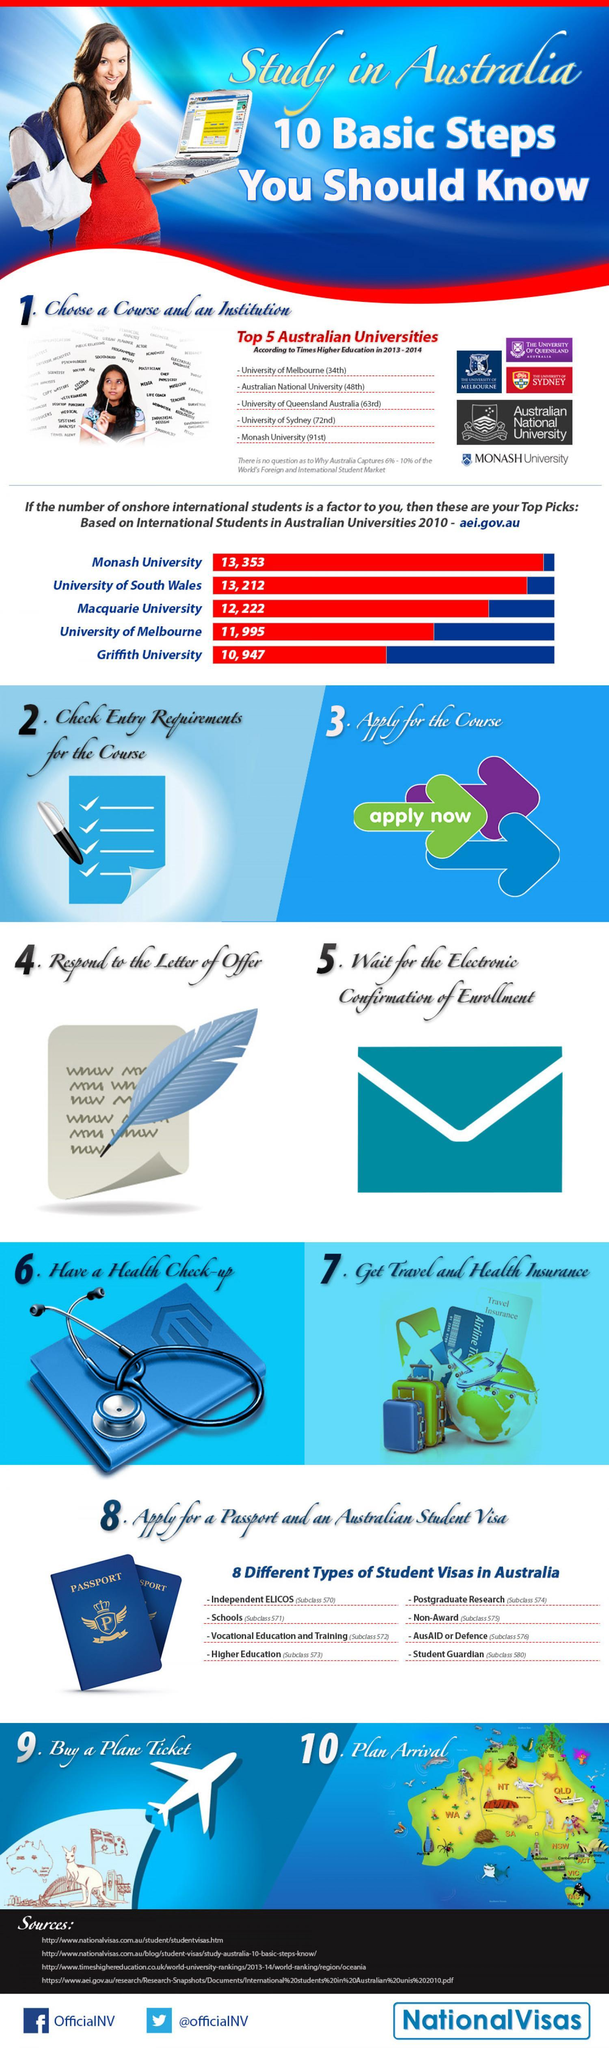Which Australian University comes in third among the Top 5 according to Times Higher Education in 2013-2014?
Answer the question with a short phrase. University of Queensland Australia Which Australian University comes in fifth among the Top 5 based on International students in Australian Universities 2010? Griffith University Which Australian University comes in fourth among the Top 5 based on International students in Australian Universities 2010? University of Melbourne Which Australian University comes in third among the Top 5 based on International students in Australian Universities 2010? Macquarie University Which Australian University comes in fourth among the Top 5 according to Times Higher Education in 2013-2014? University of Sydney Which Australian University comes in second among the Top 5 based on International students in Australian Universities 2010? University of South Wales 